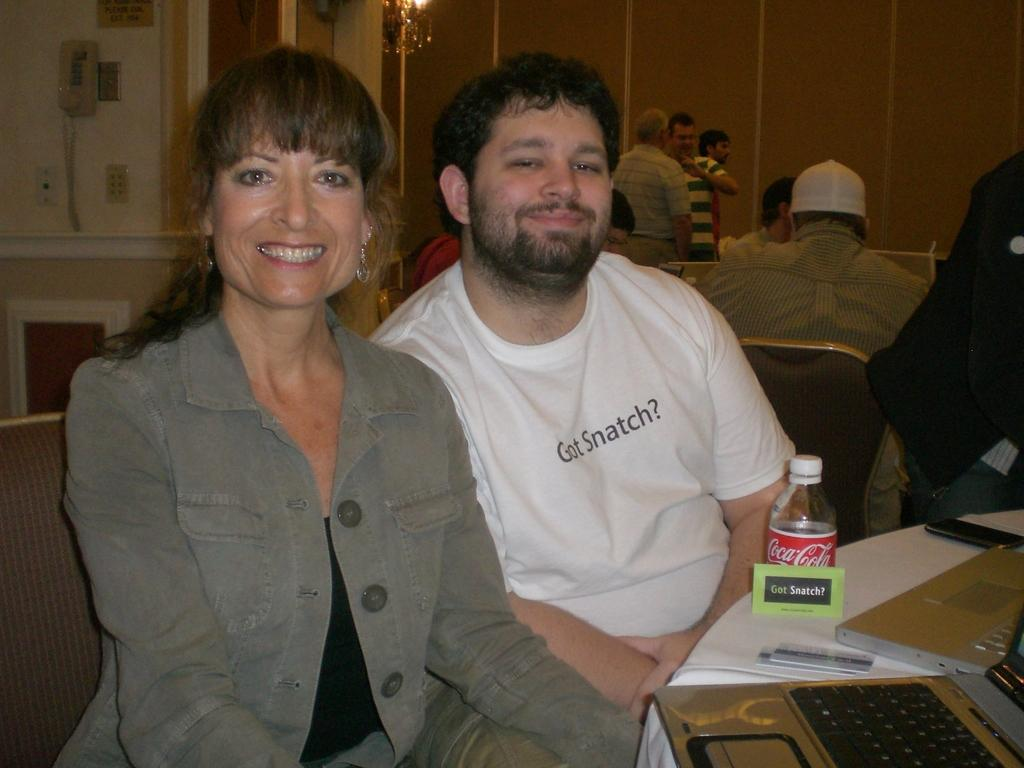How many people are in the image? There is a group of people in the image. What are some of the people doing in the image? Some people are sitting on chairs, while others are standing. What can be seen on the table in the image? There is a bottle, a laptop, and a mobile on the table. What might be used for holding objects in the image? The table can be used for holding objects, such as the bottle, laptop, and mobile. How many boys are sitting on the board in the image? There is no board or boys present in the image. What type of support is provided by the laptop in the image? The laptop does not provide any support in the image; it is an electronic device used for various purposes. 